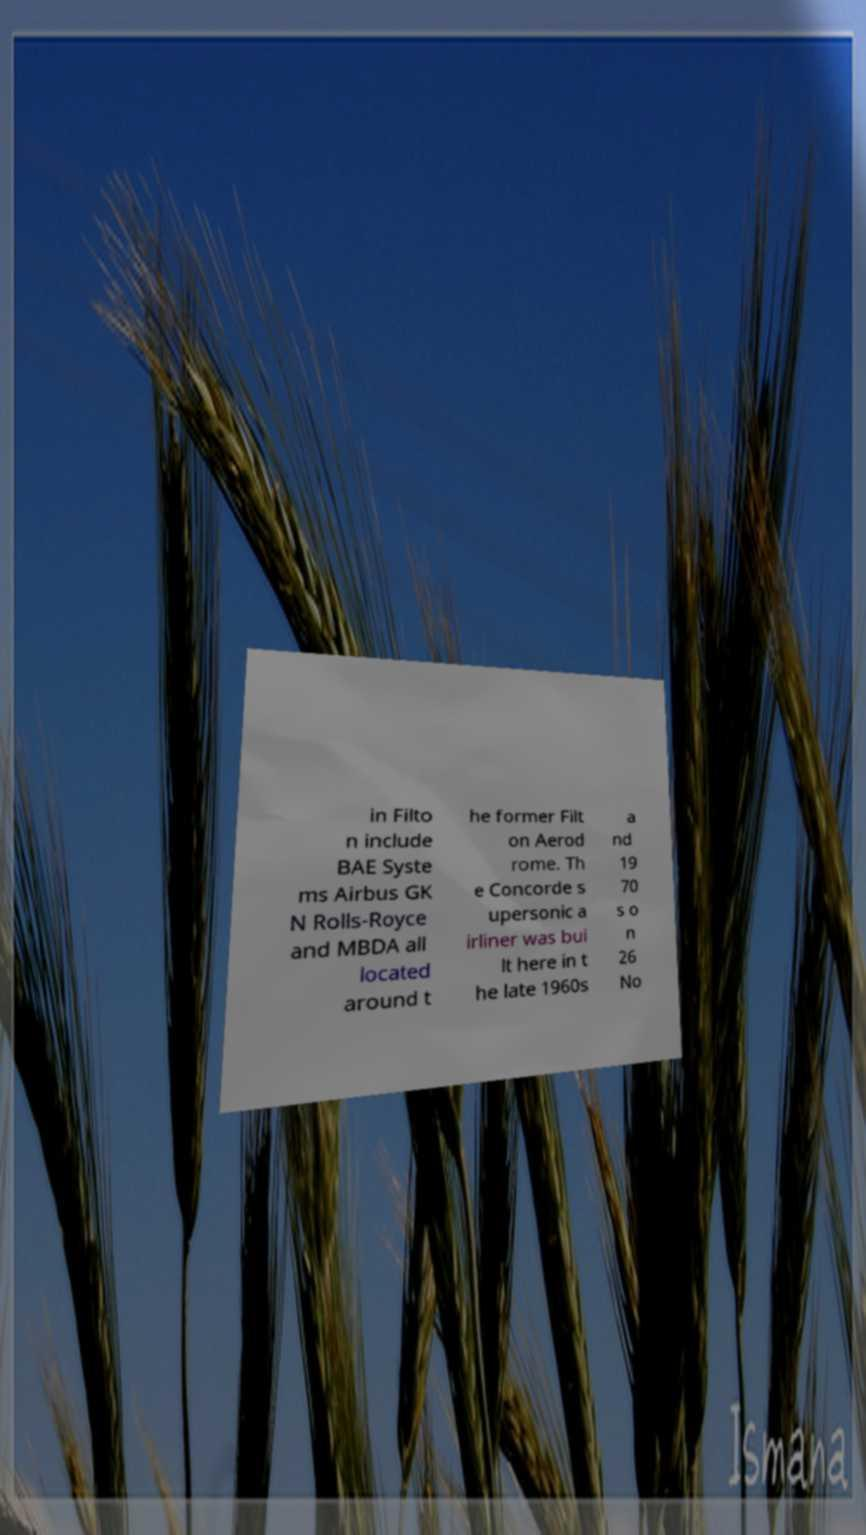Could you assist in decoding the text presented in this image and type it out clearly? in Filto n include BAE Syste ms Airbus GK N Rolls-Royce and MBDA all located around t he former Filt on Aerod rome. Th e Concorde s upersonic a irliner was bui lt here in t he late 1960s a nd 19 70 s o n 26 No 